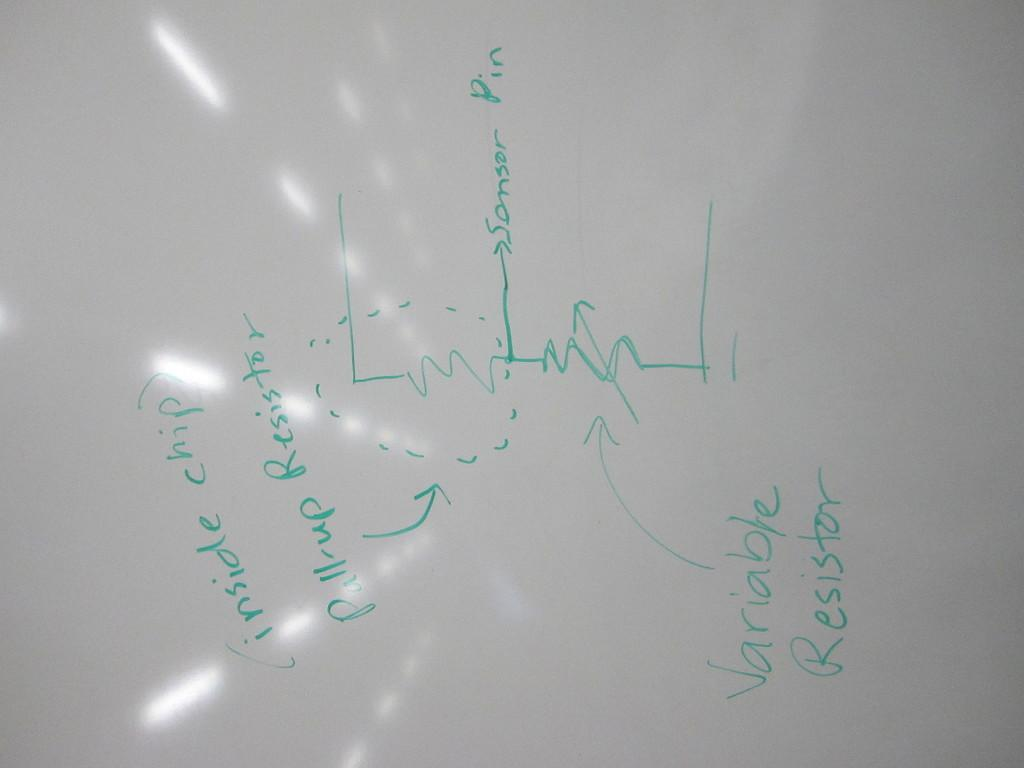<image>
Write a terse but informative summary of the picture. A white board has a diagram that is headed with the words 'inside chip'. 